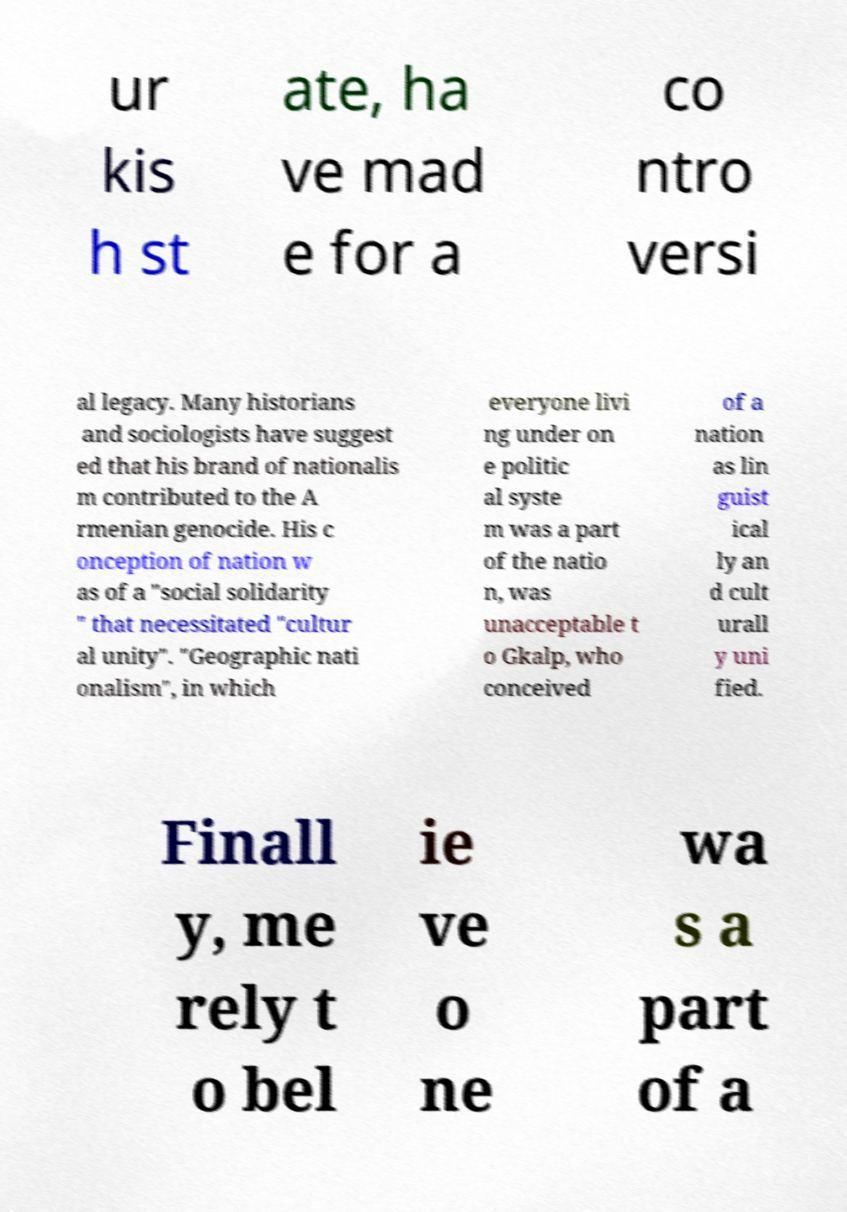Please identify and transcribe the text found in this image. ur kis h st ate, ha ve mad e for a co ntro versi al legacy. Many historians and sociologists have suggest ed that his brand of nationalis m contributed to the A rmenian genocide. His c onception of nation w as of a "social solidarity " that necessitated "cultur al unity". "Geographic nati onalism", in which everyone livi ng under on e politic al syste m was a part of the natio n, was unacceptable t o Gkalp, who conceived of a nation as lin guist ical ly an d cult urall y uni fied. Finall y, me rely t o bel ie ve o ne wa s a part of a 